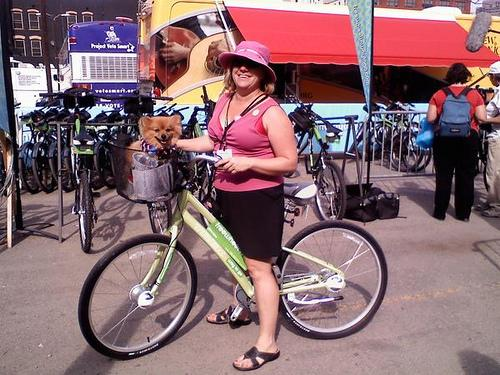What kind of accessory should the woman wear?

Choices:
A) scarf
B) wristbands
C) gloves
D) sports shoes sports shoes 